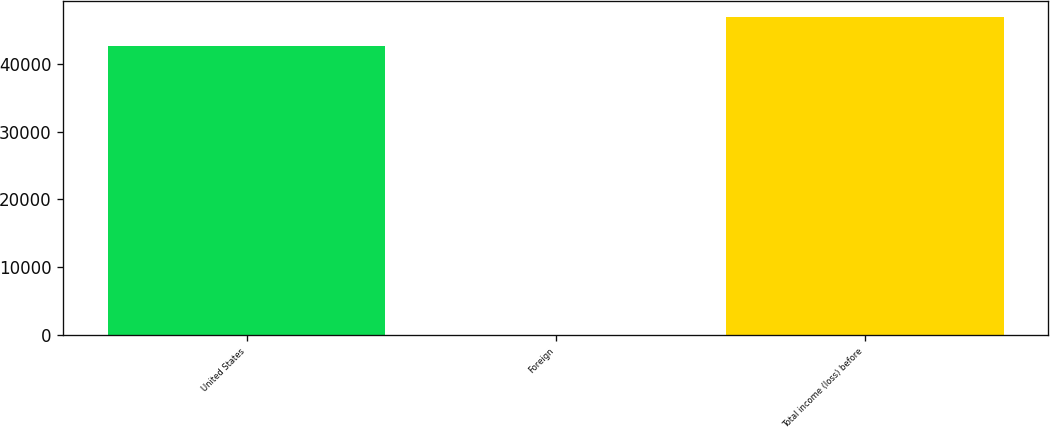Convert chart to OTSL. <chart><loc_0><loc_0><loc_500><loc_500><bar_chart><fcel>United States<fcel>Foreign<fcel>Total income (loss) before<nl><fcel>42612<fcel>8<fcel>46873.2<nl></chart> 